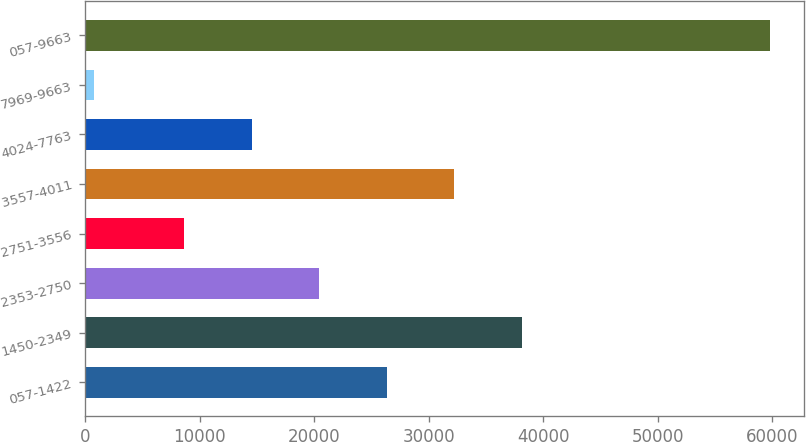<chart> <loc_0><loc_0><loc_500><loc_500><bar_chart><fcel>057-1422<fcel>1450-2349<fcel>2353-2750<fcel>2751-3556<fcel>3557-4011<fcel>4024-7763<fcel>7969-9663<fcel>057-9663<nl><fcel>26355.6<fcel>38164<fcel>20451.4<fcel>8643<fcel>32259.8<fcel>14547.2<fcel>788<fcel>59830<nl></chart> 